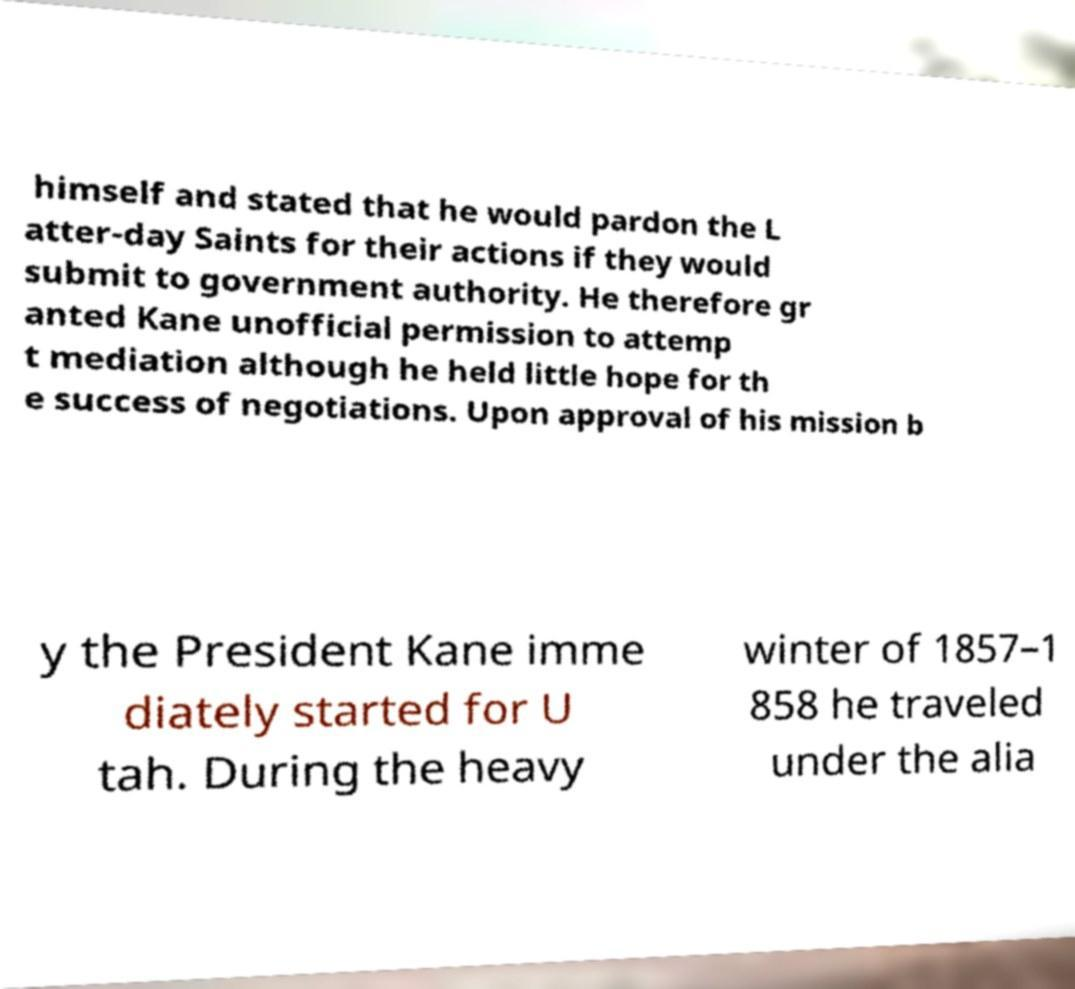What messages or text are displayed in this image? I need them in a readable, typed format. himself and stated that he would pardon the L atter-day Saints for their actions if they would submit to government authority. He therefore gr anted Kane unofficial permission to attemp t mediation although he held little hope for th e success of negotiations. Upon approval of his mission b y the President Kane imme diately started for U tah. During the heavy winter of 1857–1 858 he traveled under the alia 